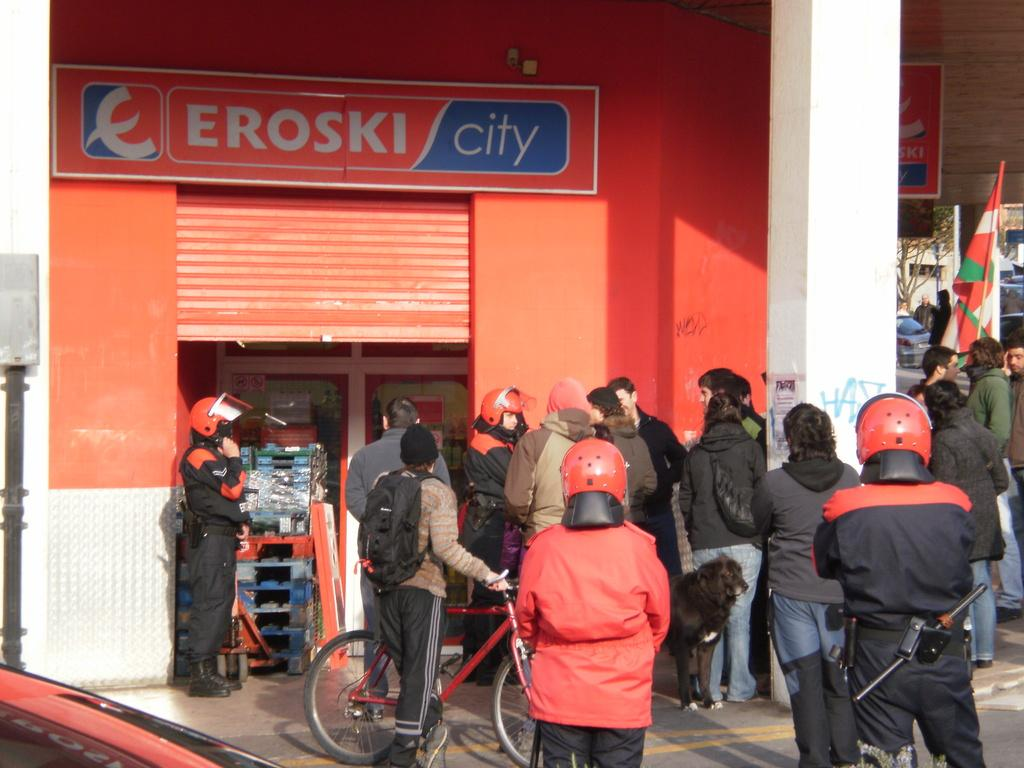Who is present in the image? There are people in the image. What are the people wearing on their heads? The people are wearing helmets. Where are the people standing in the image? The people are standing in front of a shop. Can you see a cat jumping in the image? There is no cat or jumping activity present in the image. 